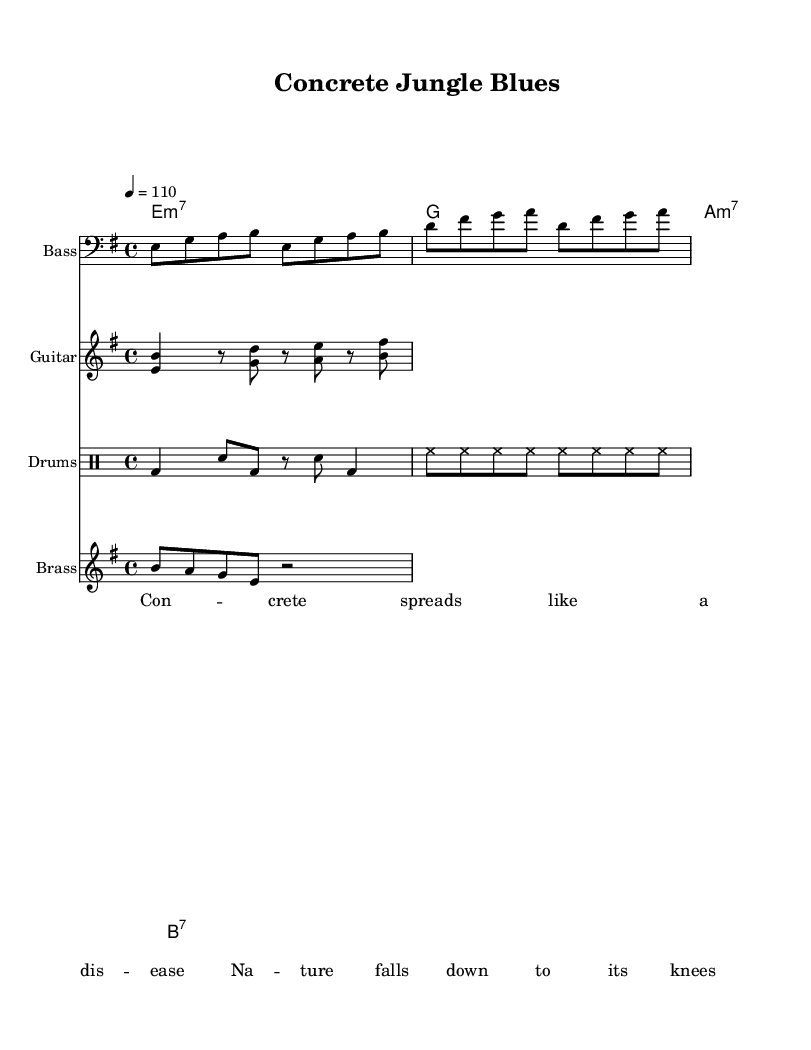What is the key signature of this music? The key signature appears at the beginning of the music and indicates it is in E minor, which has one sharp (F#).
Answer: E minor What is the time signature of this music? The time signature is shown at the beginning of the sheet music, indicating that the piece is in 4/4 time, meaning there are four beats in each measure.
Answer: 4/4 What is the tempo marking for this piece? The tempo is indicated with the marking "4 = 110," meaning there are 110 quarter note beats per minute.
Answer: 110 How many instruments are scored in this piece? By examining the score section, we can see there are four parts specified: Bass, Guitar, Drums, and Brass.
Answer: Four What type of chord is the first in the progression? The chord symbol in the chord mode for the first measure shows "e:m7," indicating it is an E minor 7 chord.
Answer: E minor 7 What rhythmic pattern do the drums follow? The drum pattern consists of a combination of bass drum, snare, and hi-hat sequences, with alternating quarter and eighth notes.
Answer: Mixed What social issue is highlighted in the lyrics of this piece? The lyrics contain messages about nature suffering due to urban development and consumerism, indicating a critique of societal issues related to car culture and environmental degradation.
Answer: Consumerism 